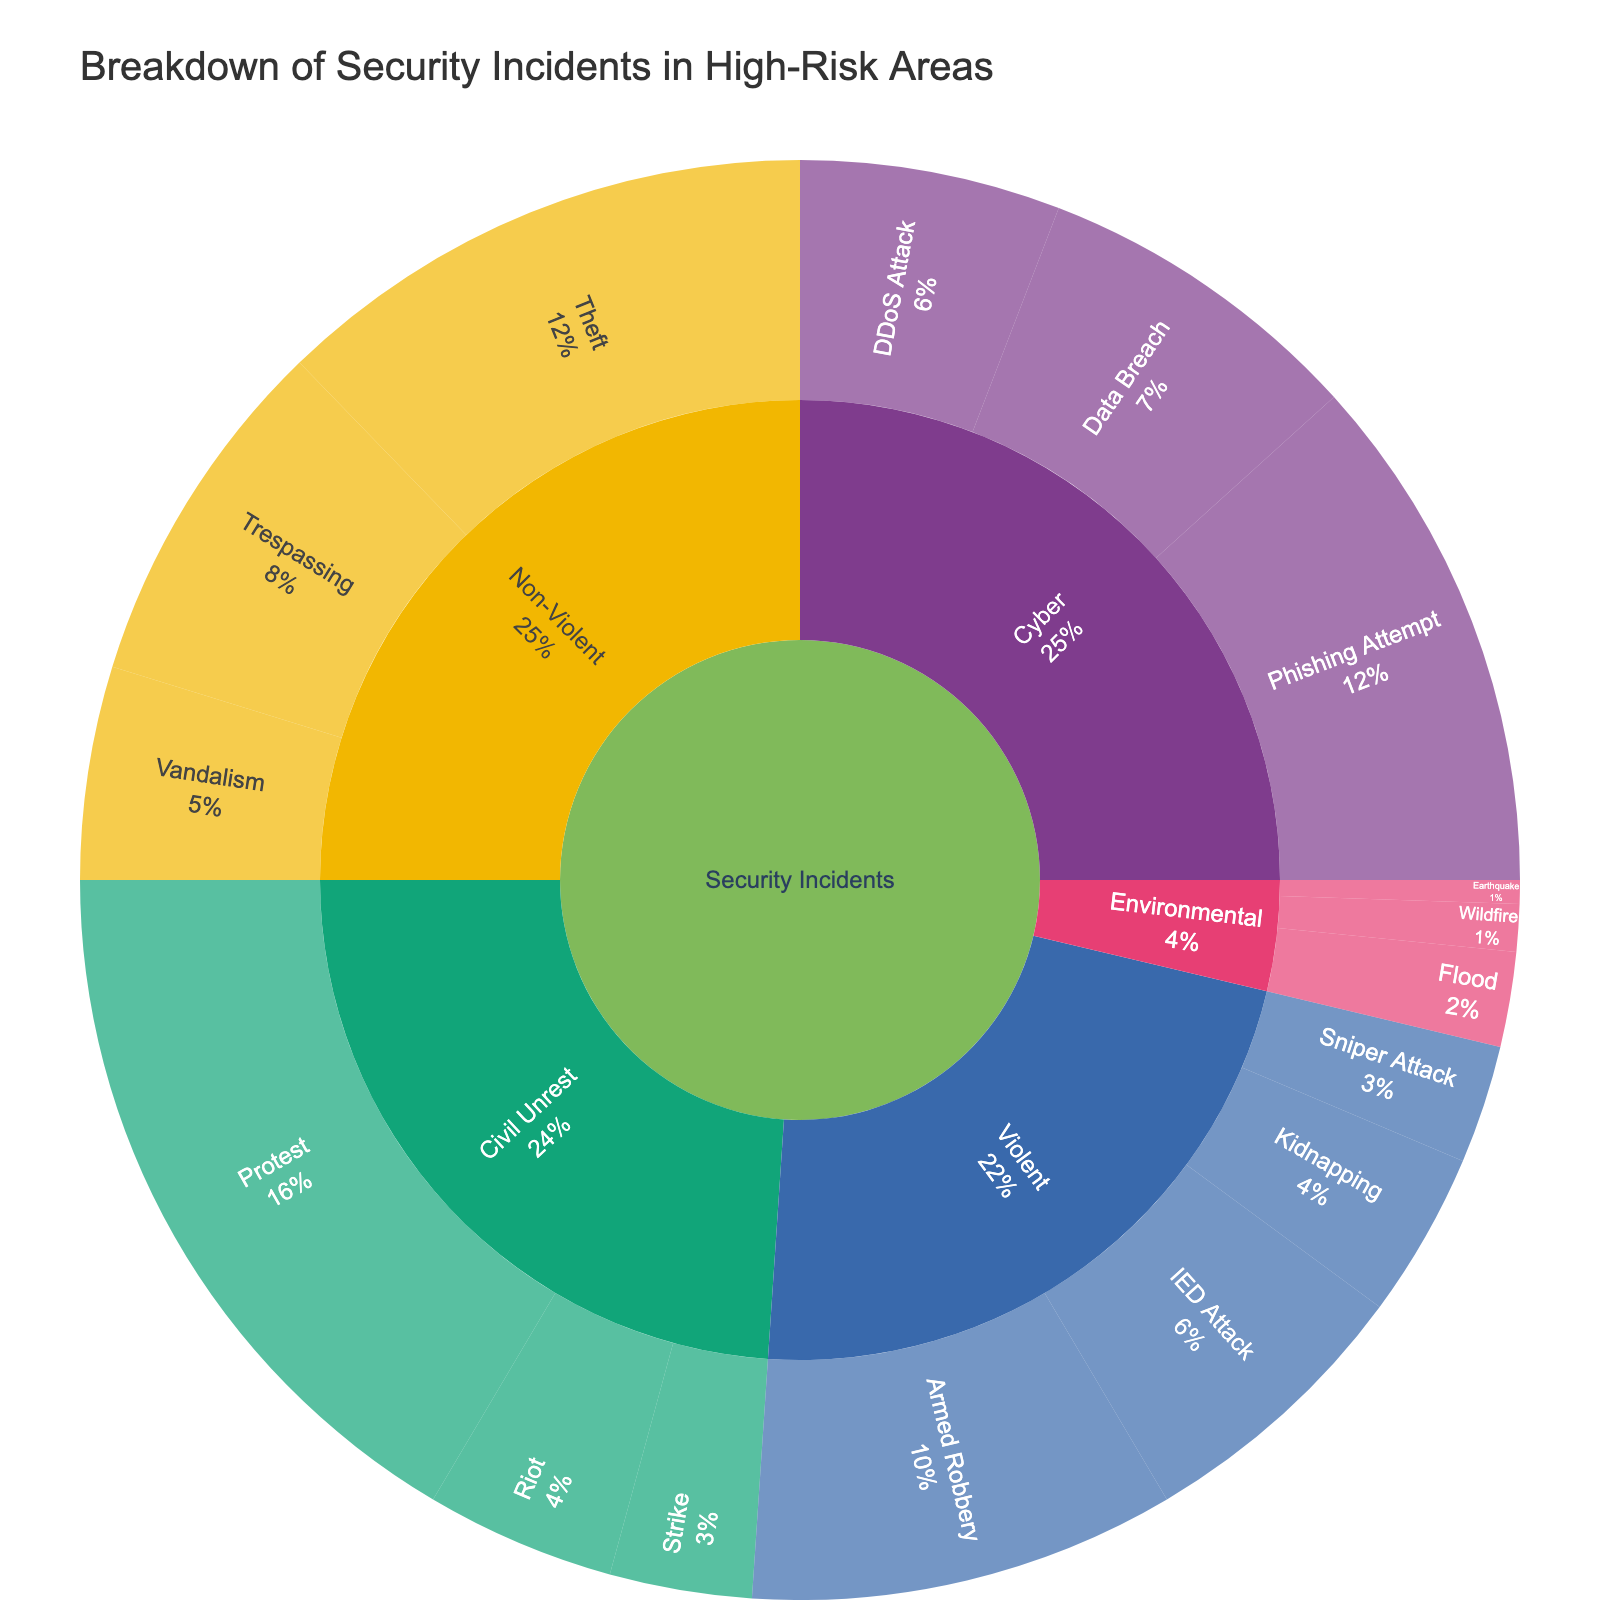What is the title of the sunburst plot? The title of the plot is usually displayed at the top of the figure. In this case, it reads "Breakdown of Security Incidents in High-Risk Areas".
Answer: Breakdown of Security Incidents in High-Risk Areas Which category has the highest count as shown in the sunburst plot? The innermost circle of the sunburst plot represents the different categories. To identify the category with the highest count, you look for the largest segment in the innermost circle.
Answer: Security Incidents How many counts are there under the 'Cyber' type? Look at the segment labeled 'Cyber' and sum the counts of its subtypes: Data Breach (14), Phishing Attempt (22), and DDoS Attack (11). The sum is 14 + 22 + 11.
Answer: 47 What percentage of incidents are categorized as violent? The percentage can be derived by considering the segments under 'Violent' in relation to the total. Violent incidents include Armed Robbery, Kidnapping, IED Attack, and Sniper Attack, summing to 18+7+12+5 = 42. The total count for all incidents can be summed from the data provided.
Answer: 27.10% What is the count for the least frequent environmental incident? Look at the segments under 'Environmental' and identify the one with the lowest count. Earthquake is noted to have the least count with a value of 1.
Answer: 1 Compare the counts of 'Protest' and 'Riot' under Civil Unrest. Which is higher? Examine the segments under 'Civil Unrest'. The count for 'Protest' is 31 and for 'Riot' it is 8. 'Protest' has a higher count.
Answer: Protest What is the combined count of non-violent incidents? Sum the counts of all the 'Non-Violent' subtypes: Theft (23), Trespassing (15), and Vandalism (9). The combined count is 23 + 15 + 9.
Answer: 47 Which subtype has the highest count in the 'Violent' category? Look at the subtypes under 'Violent' and find the one with the highest count. Armed Robbery has the highest count of 18.
Answer: Armed Robbery How many subtypes are there under the 'Civil Unrest' type? Count the number of different subtypes under 'Civil Unrest': Protest, Riot, and Strike. There are three subtypes.
Answer: 3 What is the overall count of incidents in high-risk areas? Sum all the counts provided in the data to find the total. Add: 18+7+12+5+23+15+9+31+8+6+14+22+11+4+2+1 for the total.
Answer: 188 